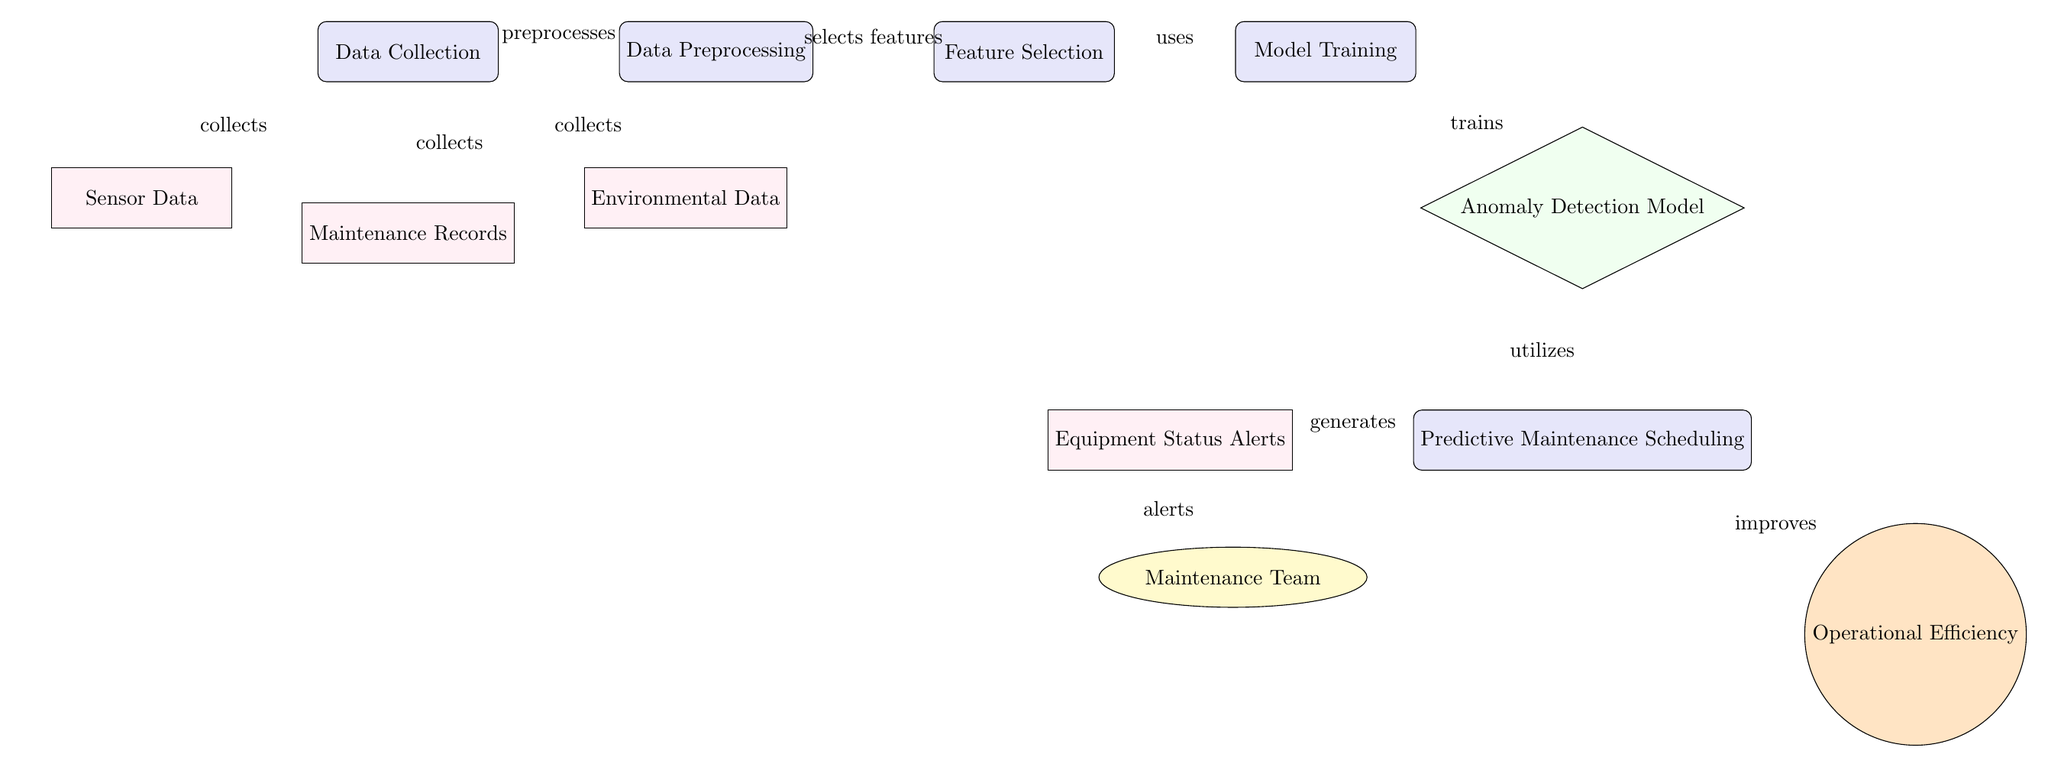What's the first process in the diagram? The diagram shows the first node on the left as "Data Collection."
Answer: Data Collection How many types of data are collected during the "Data Collection"? There are three types of data listed: Sensor Data, Maintenance Records, and Environmental Data, which are visually represented as three separate nodes below the "Data Collection" process node.
Answer: Three What is the output of the "Predictive Maintenance Scheduling" process? The output of the "Predictive Maintenance Scheduling" process, represented by arrows emanating from it, includes "Equipment Status Alerts" and the improvement of "Operational Efficiency."
Answer: Equipment Status Alerts and Operational Efficiency What role does the "Anomaly Detection Model" play in the diagram? The "Anomaly Detection Model," which is below the "Model Training" process, is utilized by the “Predictive Maintenance Scheduling” process, indicating its role in identifying anomalies in the data to aid in scheduling maintenance.
Answer: Utilizes Which data type is indicated to generate alerts for the Maintenance Team? The "Equipment Status Alerts" data type is indicated to generate alerts for the Maintenance Team, as shown in the flow from the "Predictive Maintenance Scheduling" process to the "Maintenance Team" node.
Answer: Equipment Status Alerts What does the "Model Training" process use from the "Feature Selection"? The "Model Training" process uses the selected features from the "Feature Selection" process, demonstrating that features need to be selected before model training can occur.
Answer: Uses What is the relationship between "Predictive Maintenance Scheduling" and "Operational Efficiency"? The relationship indicates that "Predictive Maintenance Scheduling" improves "Operational Efficiency," as shown by the directional arrow connecting the two nodes in the diagram.
Answer: Improves What is the position of the "Data Preprocessing" process relative to "Data Collection"? The "Data Preprocessing" process is positioned directly to the right of the "Data Collection" process, indicating a sequential flow where data preprocessing follows the initial data collection.
Answer: Right 